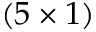Convert formula to latex. <formula><loc_0><loc_0><loc_500><loc_500>( 5 \times 1 )</formula> 